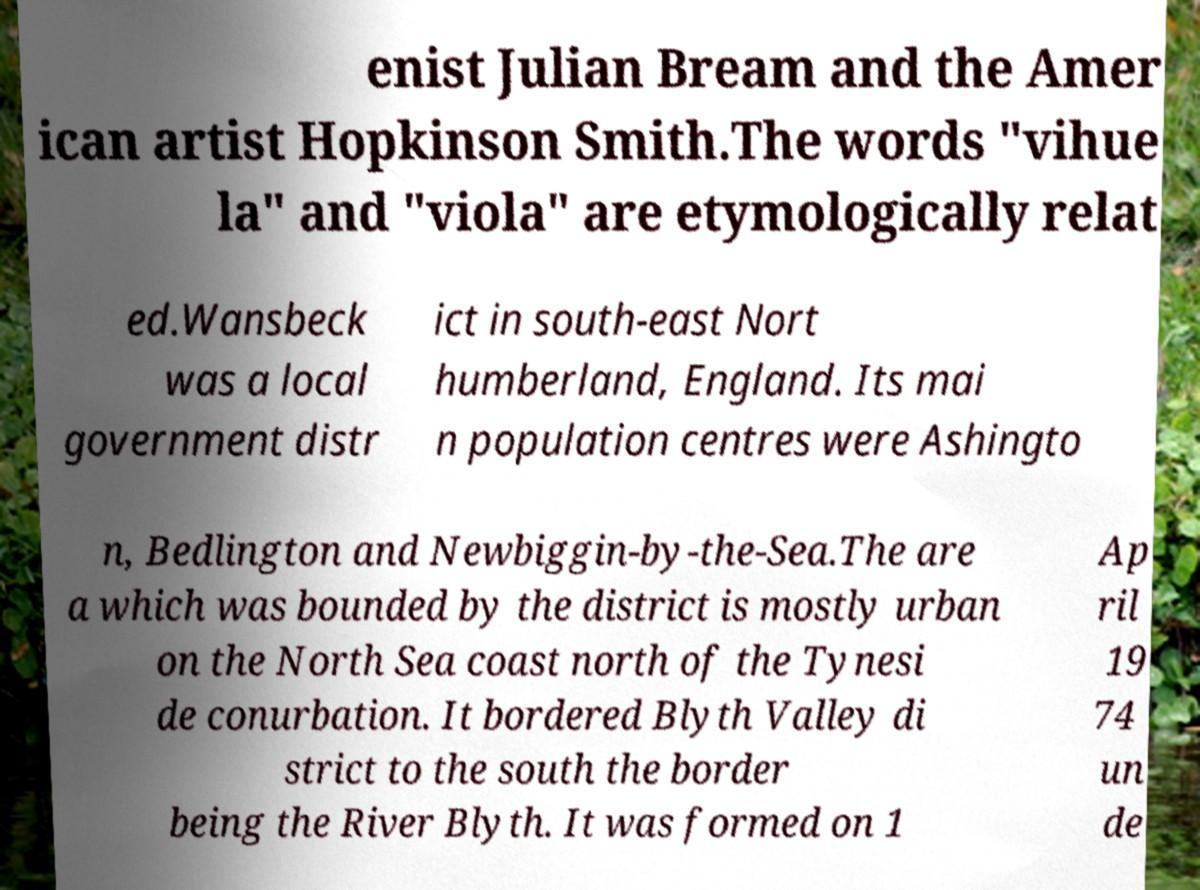Please read and relay the text visible in this image. What does it say? enist Julian Bream and the Amer ican artist Hopkinson Smith.The words "vihue la" and "viola" are etymologically relat ed.Wansbeck was a local government distr ict in south-east Nort humberland, England. Its mai n population centres were Ashingto n, Bedlington and Newbiggin-by-the-Sea.The are a which was bounded by the district is mostly urban on the North Sea coast north of the Tynesi de conurbation. It bordered Blyth Valley di strict to the south the border being the River Blyth. It was formed on 1 Ap ril 19 74 un de 